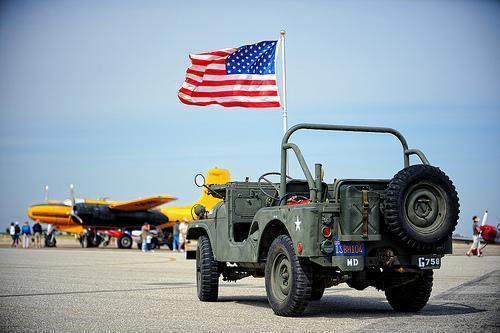How many tires does the jeep have?
Give a very brief answer. 5. How many jeeps?
Give a very brief answer. 1. 